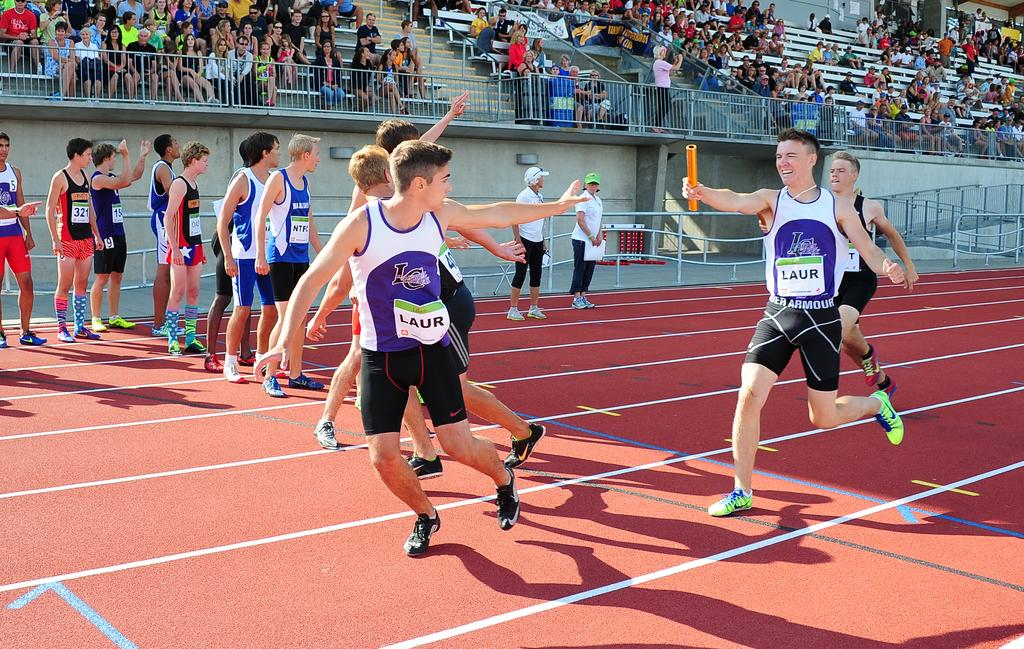<image>
Summarize the visual content of the image. Two teammates running a relay race with the word "LAUR" written on their shirts. 